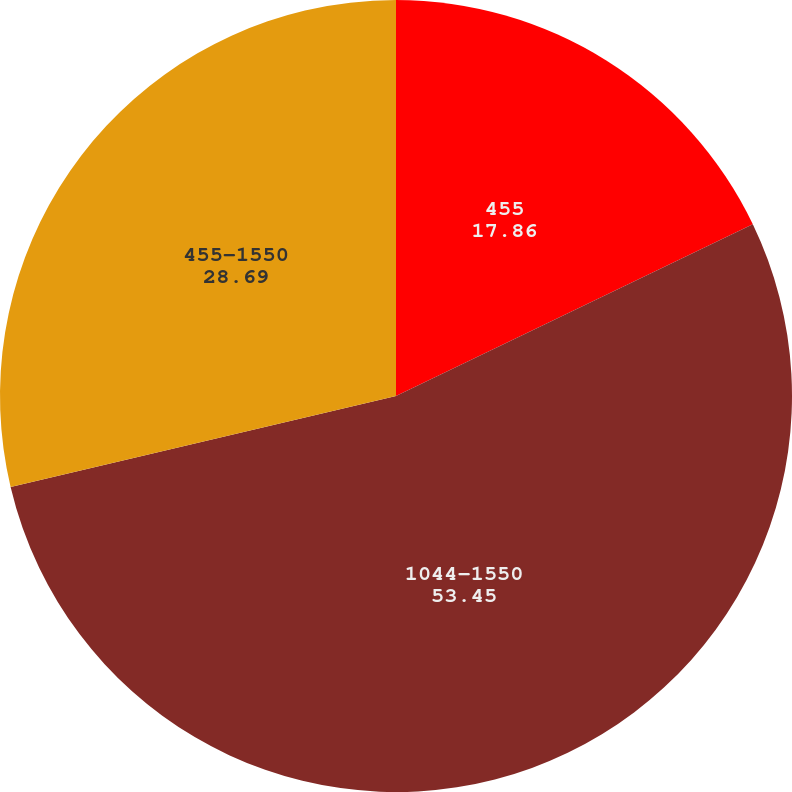Convert chart to OTSL. <chart><loc_0><loc_0><loc_500><loc_500><pie_chart><fcel>455<fcel>1044-1550<fcel>455-1550<nl><fcel>17.86%<fcel>53.45%<fcel>28.69%<nl></chart> 